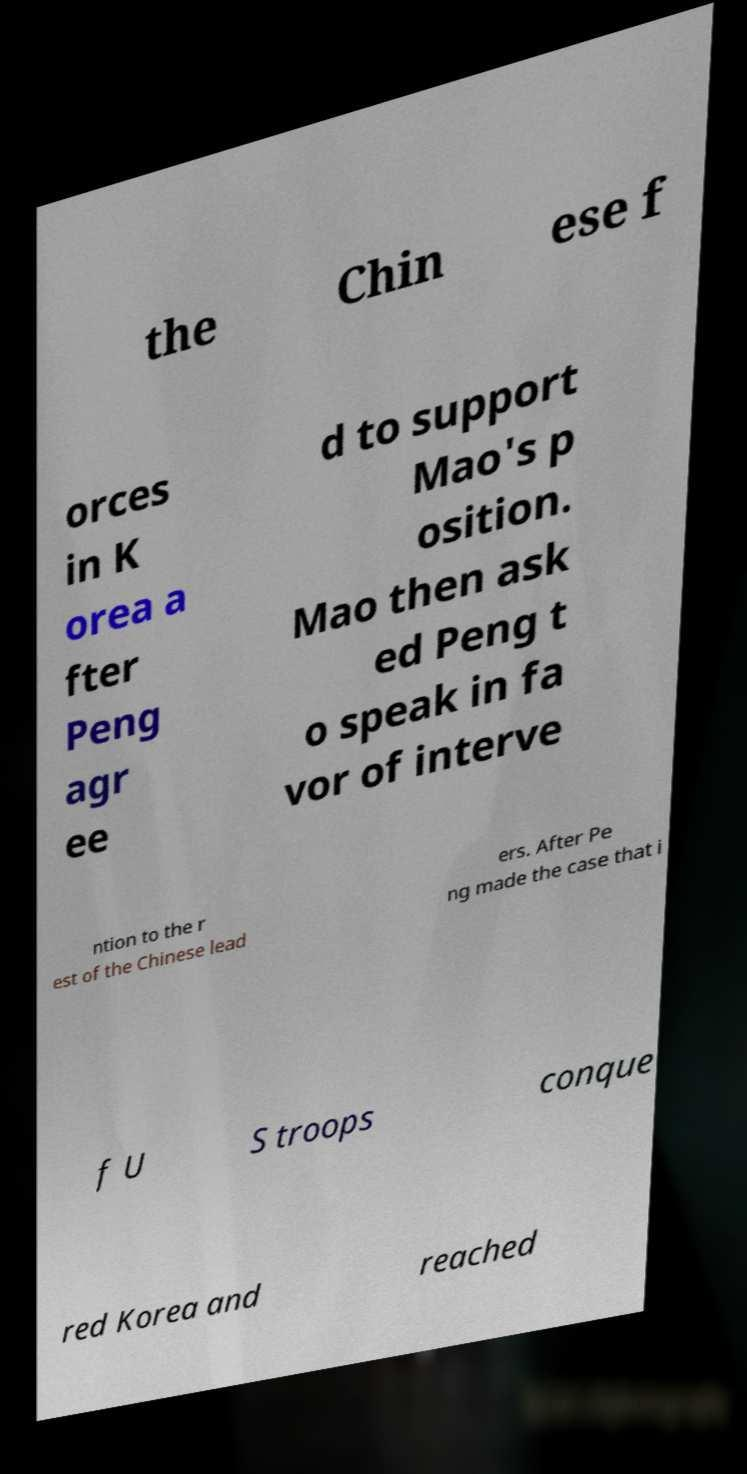Please identify and transcribe the text found in this image. the Chin ese f orces in K orea a fter Peng agr ee d to support Mao's p osition. Mao then ask ed Peng t o speak in fa vor of interve ntion to the r est of the Chinese lead ers. After Pe ng made the case that i f U S troops conque red Korea and reached 